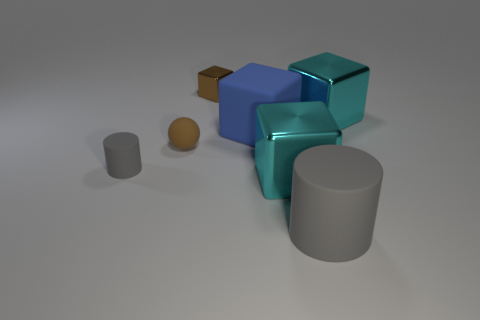Add 1 large things. How many objects exist? 8 Subtract all matte cubes. How many cubes are left? 3 Subtract all purple cylinders. How many cyan cubes are left? 2 Subtract all blue cubes. How many cubes are left? 3 Subtract 0 green cubes. How many objects are left? 7 Subtract all blocks. How many objects are left? 3 Subtract all blue spheres. Subtract all cyan cylinders. How many spheres are left? 1 Subtract all large gray rubber spheres. Subtract all blocks. How many objects are left? 3 Add 7 rubber spheres. How many rubber spheres are left? 8 Add 7 brown metal cubes. How many brown metal cubes exist? 8 